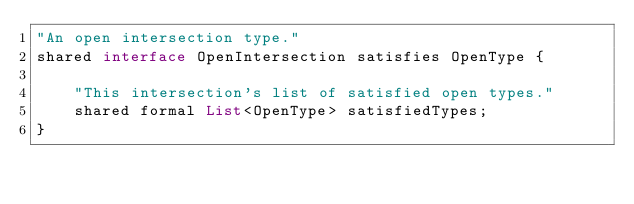Convert code to text. <code><loc_0><loc_0><loc_500><loc_500><_Ceylon_>"An open intersection type."
shared interface OpenIntersection satisfies OpenType {
    
    "This intersection's list of satisfied open types."
    shared formal List<OpenType> satisfiedTypes;
}
</code> 